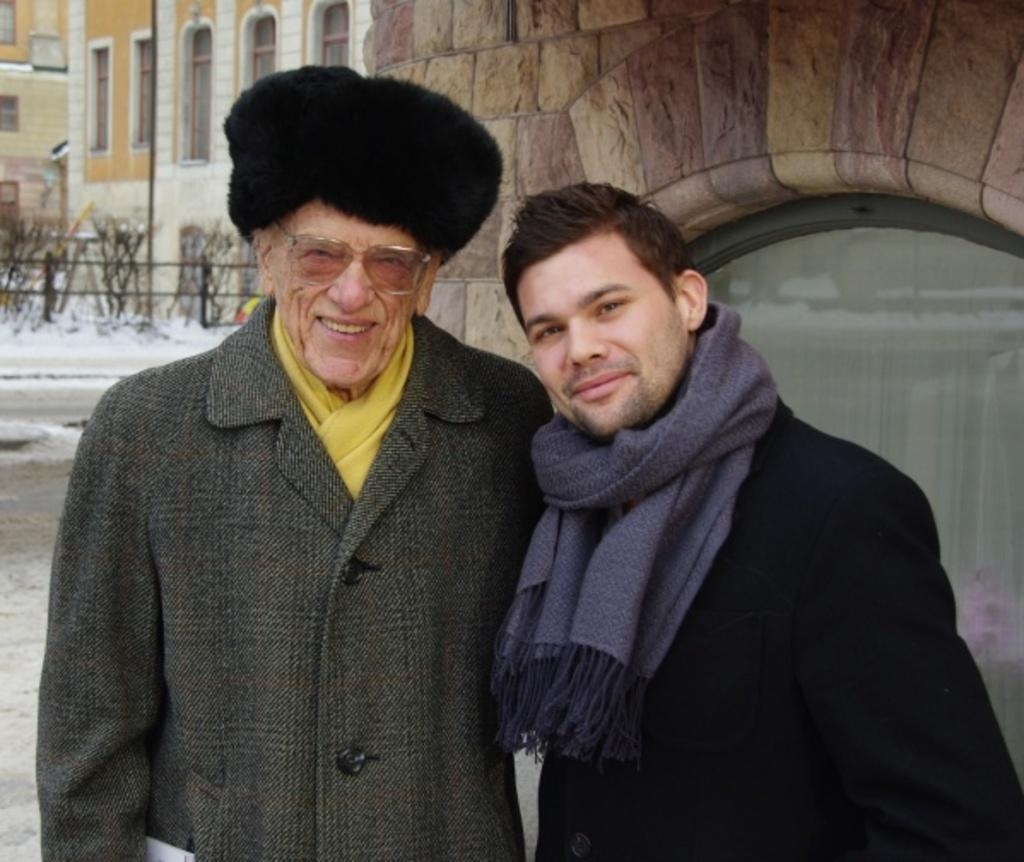How many people are in the image? There are two people in the image. What are the people wearing? The people are wearing different color dresses. What can be seen in the background of the image? There is a railing, a planter, a fence, and a pole in the background of the image. What type of pencil is the sister holding in the image? There is no sister or pencil present in the image. Where is the drawer located in the image? There is no drawer present in the image. 